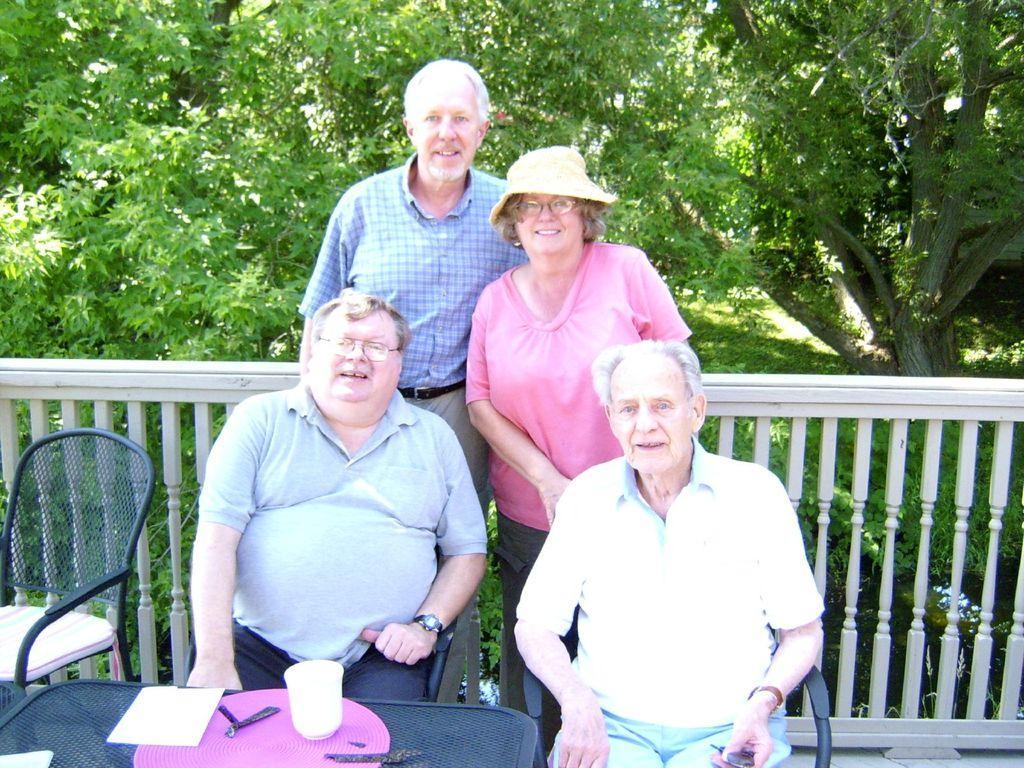Describe this image in one or two sentences. In the center of the image two mans are sitting on a chair and two persons are standing. In the background of the image we can see some trees are there. At the bottom of the image there is a table. On the table we can see paper, glass and some objects are there. On the left side of the image a chair is there. In the middle of the image fencing is there. At the bottom of the image floor is there. 